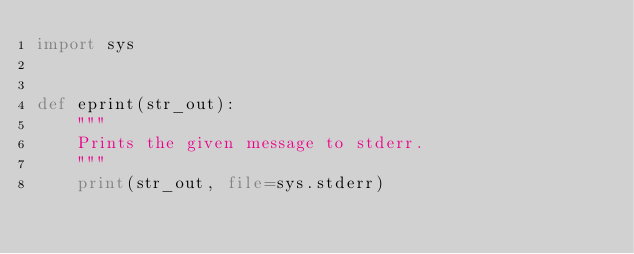Convert code to text. <code><loc_0><loc_0><loc_500><loc_500><_Python_>import sys


def eprint(str_out):
    """
    Prints the given message to stderr.
    """
    print(str_out, file=sys.stderr)
</code> 